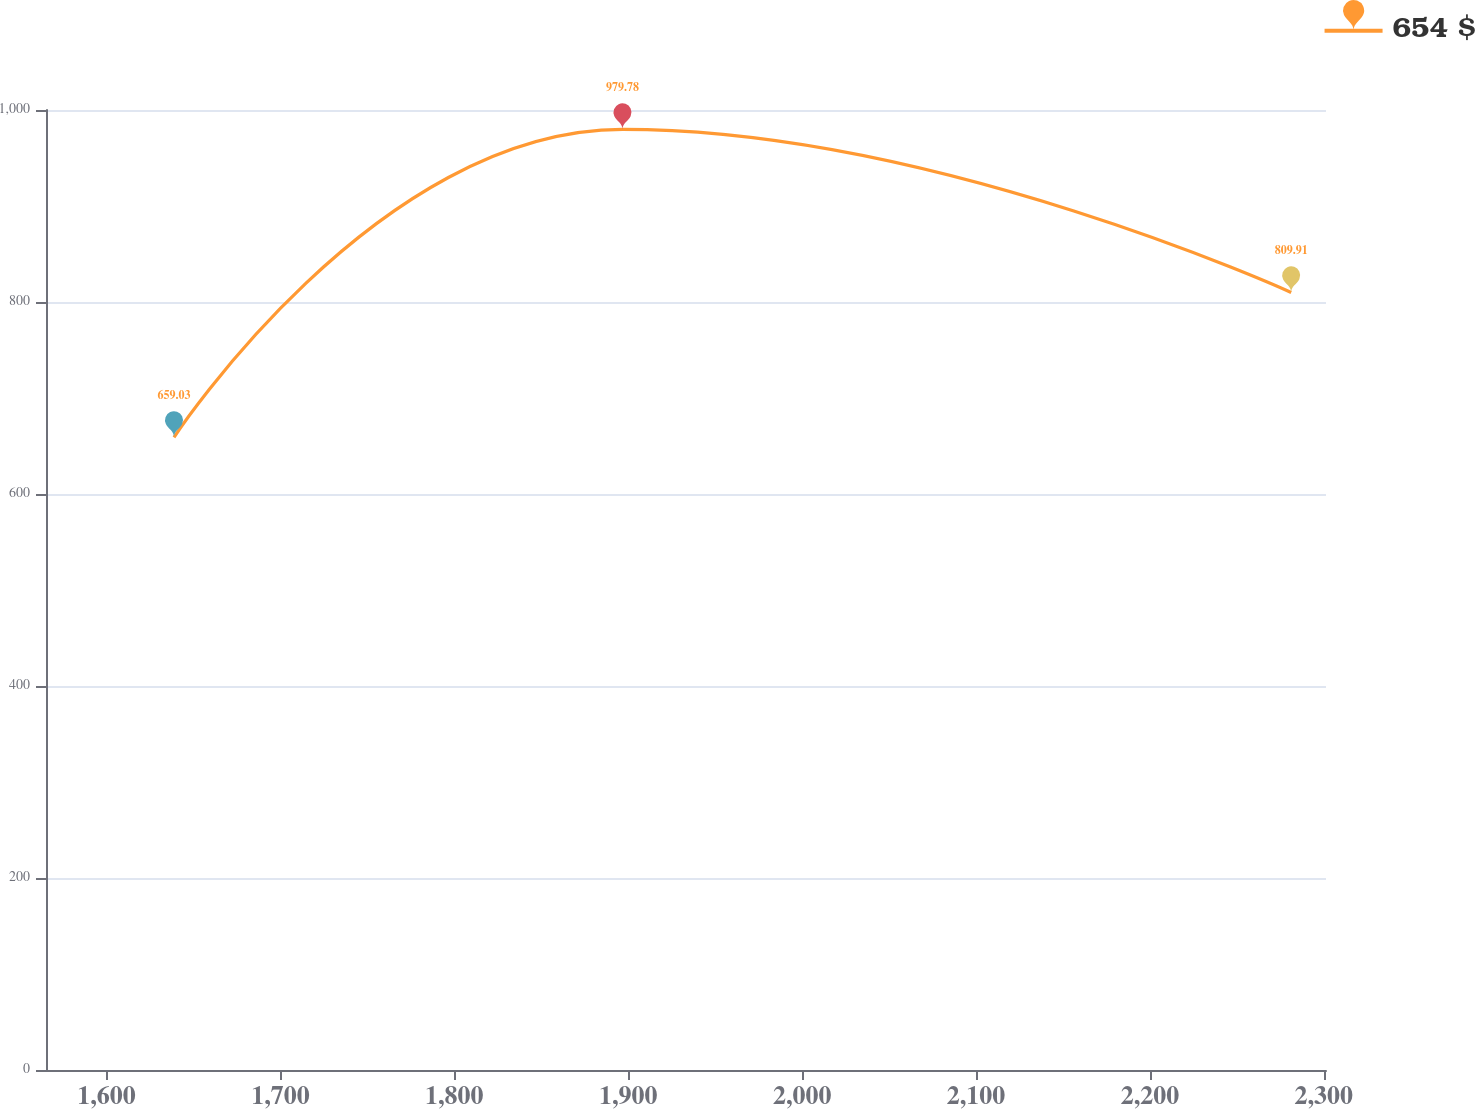Convert chart. <chart><loc_0><loc_0><loc_500><loc_500><line_chart><ecel><fcel>654 $<nl><fcel>1638.78<fcel>659.03<nl><fcel>1896.69<fcel>979.78<nl><fcel>2281.23<fcel>809.91<nl><fcel>2374.86<fcel>950.04<nl></chart> 